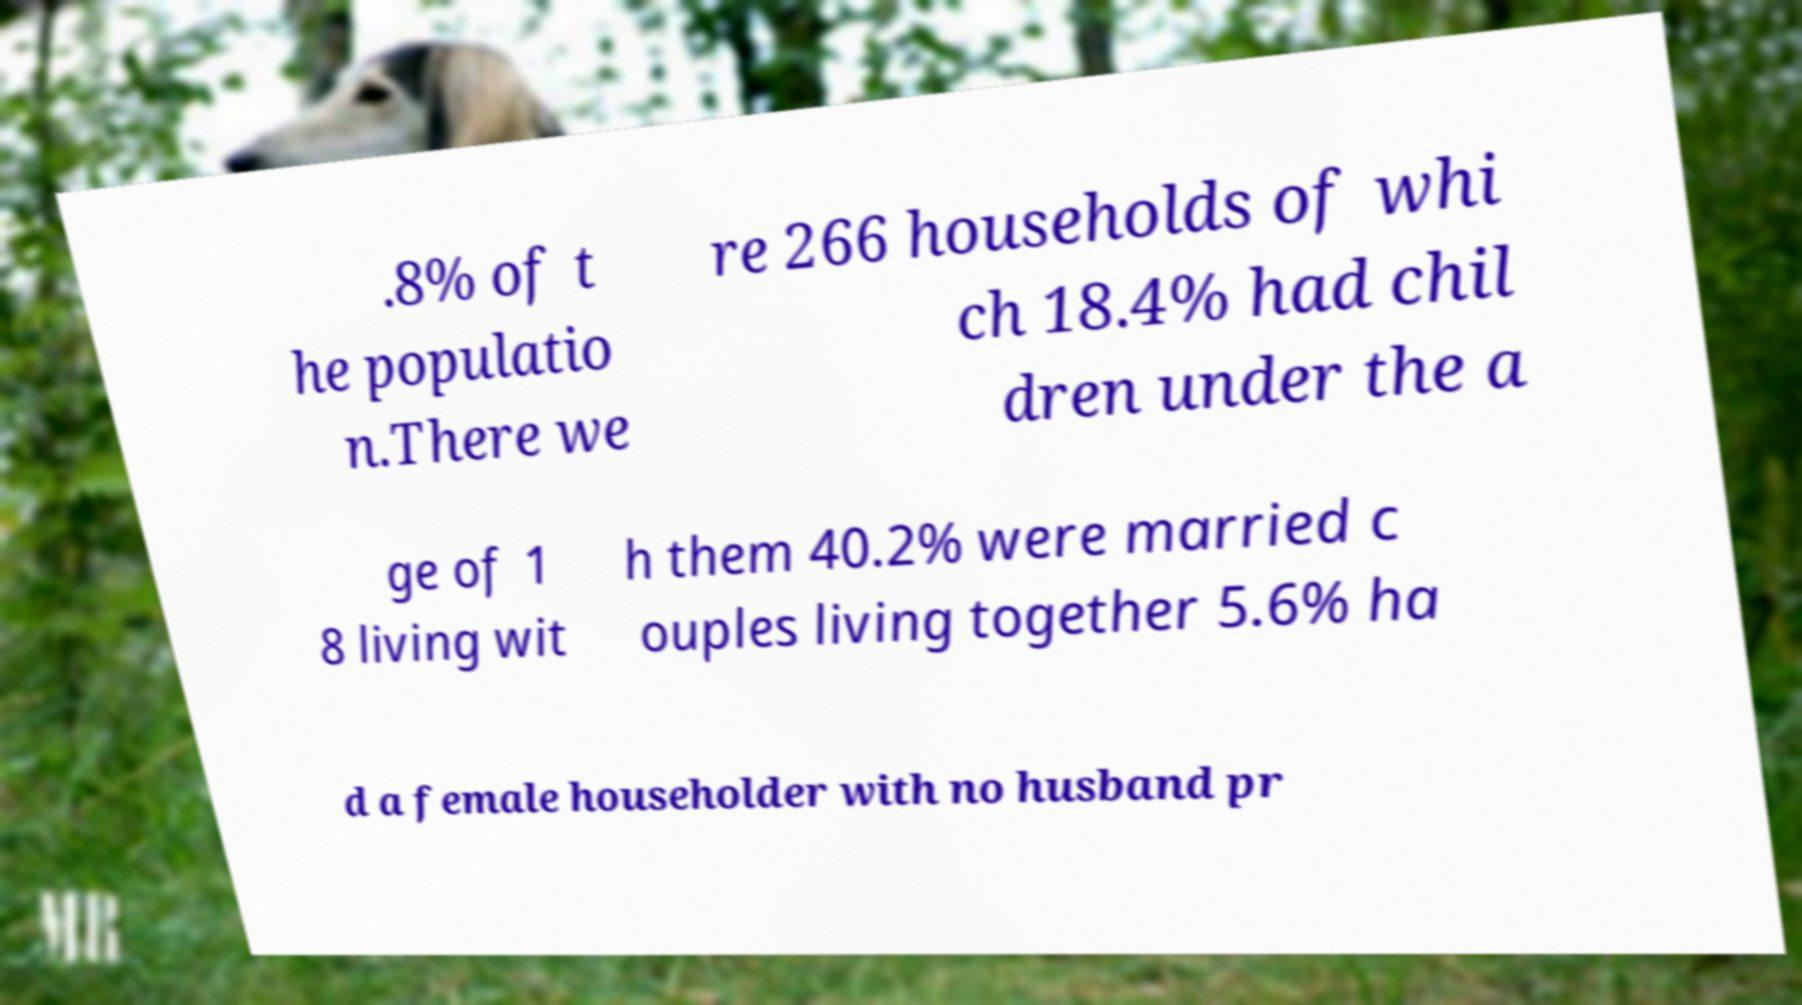Can you read and provide the text displayed in the image?This photo seems to have some interesting text. Can you extract and type it out for me? .8% of t he populatio n.There we re 266 households of whi ch 18.4% had chil dren under the a ge of 1 8 living wit h them 40.2% were married c ouples living together 5.6% ha d a female householder with no husband pr 